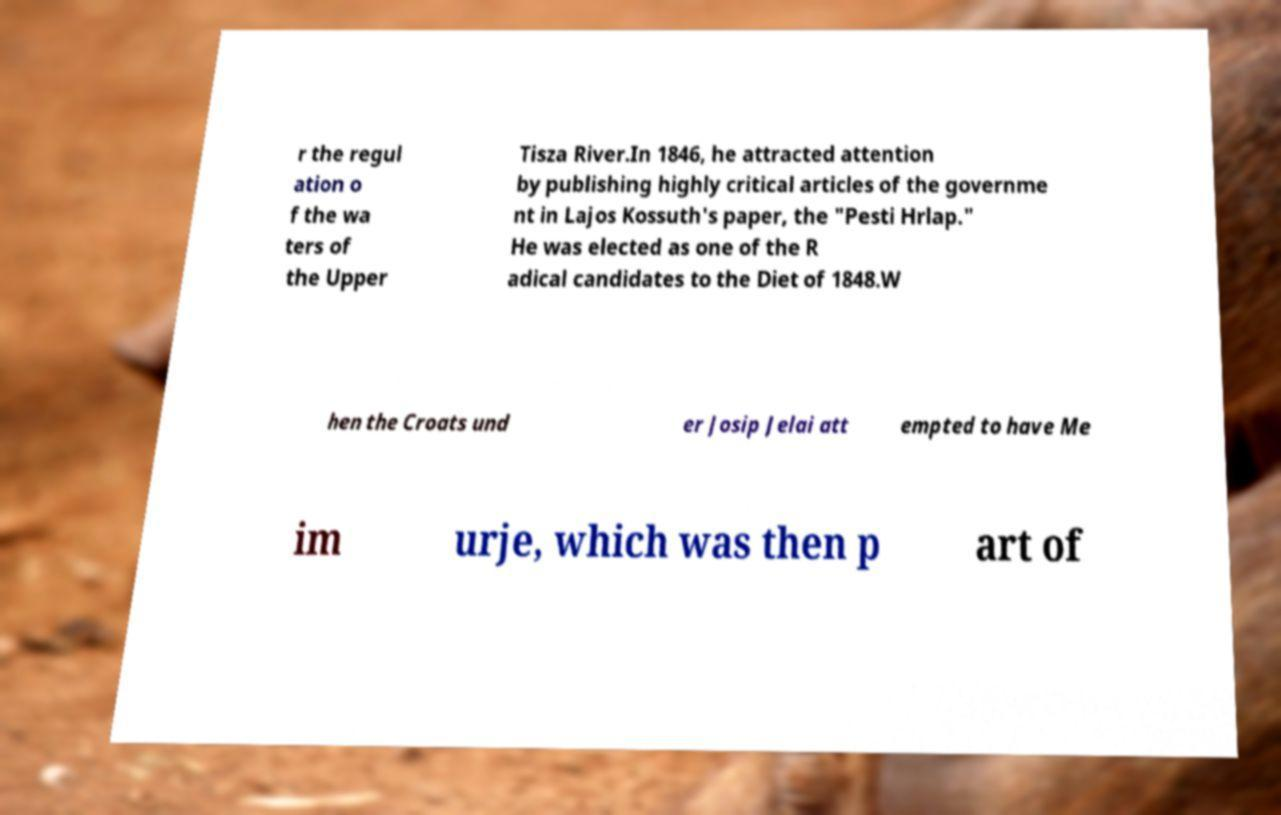I need the written content from this picture converted into text. Can you do that? r the regul ation o f the wa ters of the Upper Tisza River.In 1846, he attracted attention by publishing highly critical articles of the governme nt in Lajos Kossuth's paper, the "Pesti Hrlap." He was elected as one of the R adical candidates to the Diet of 1848.W hen the Croats und er Josip Jelai att empted to have Me im urje, which was then p art of 